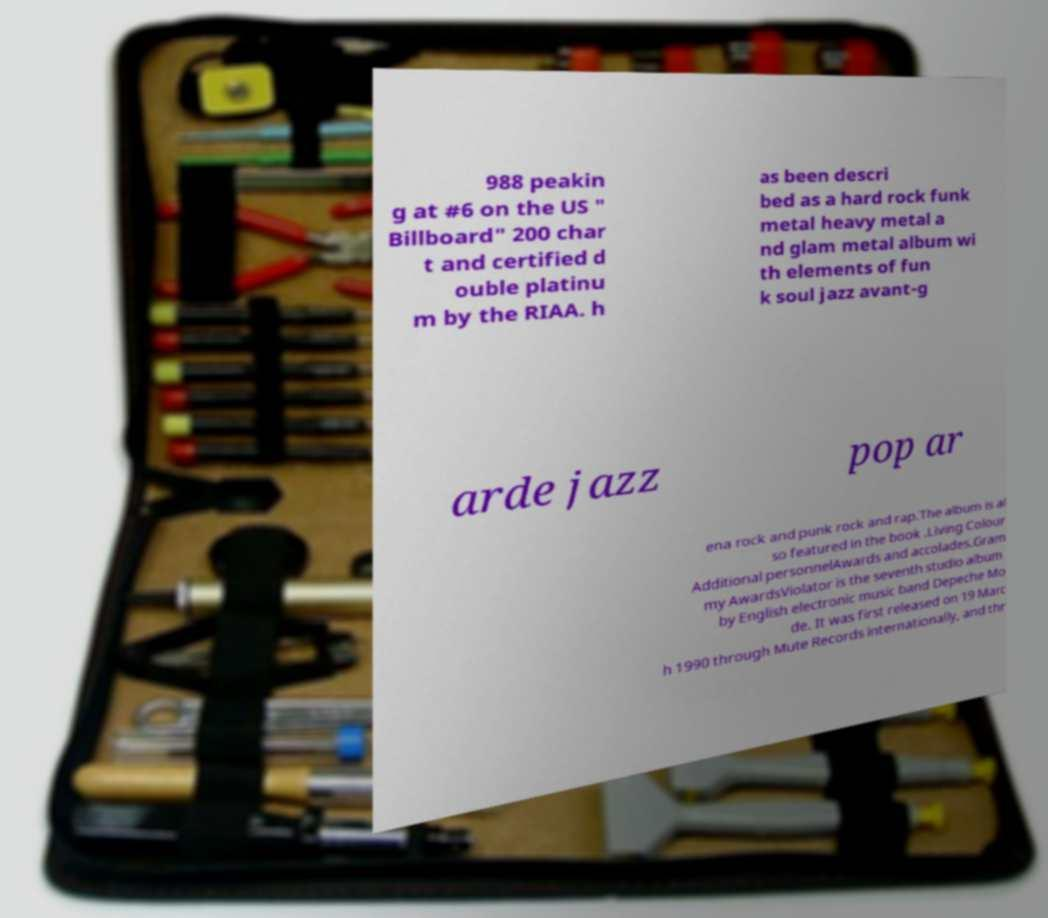Can you accurately transcribe the text from the provided image for me? 988 peakin g at #6 on the US " Billboard" 200 char t and certified d ouble platinu m by the RIAA. h as been descri bed as a hard rock funk metal heavy metal a nd glam metal album wi th elements of fun k soul jazz avant-g arde jazz pop ar ena rock and punk rock and rap.The album is al so featured in the book .Living Colour Additional personnelAwards and accolades.Gram my AwardsViolator is the seventh studio album by English electronic music band Depeche Mo de. It was first released on 19 Marc h 1990 through Mute Records internationally, and thr 